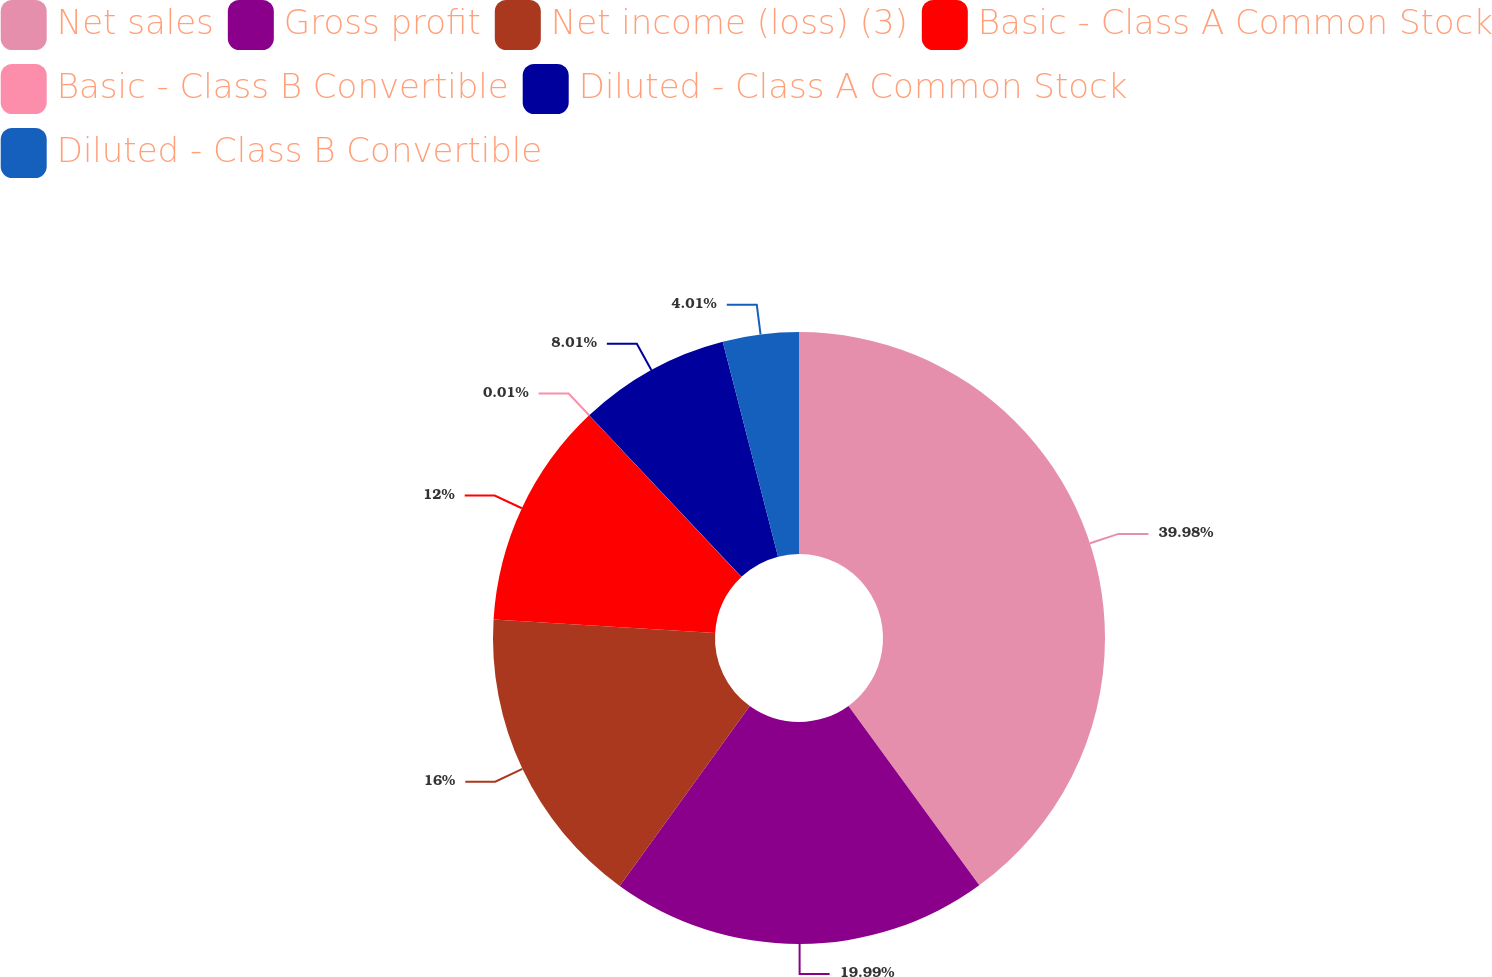<chart> <loc_0><loc_0><loc_500><loc_500><pie_chart><fcel>Net sales<fcel>Gross profit<fcel>Net income (loss) (3)<fcel>Basic - Class A Common Stock<fcel>Basic - Class B Convertible<fcel>Diluted - Class A Common Stock<fcel>Diluted - Class B Convertible<nl><fcel>39.97%<fcel>19.99%<fcel>16.0%<fcel>12.0%<fcel>0.01%<fcel>8.01%<fcel>4.01%<nl></chart> 